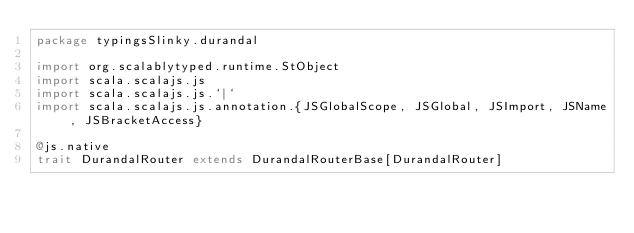<code> <loc_0><loc_0><loc_500><loc_500><_Scala_>package typingsSlinky.durandal

import org.scalablytyped.runtime.StObject
import scala.scalajs.js
import scala.scalajs.js.`|`
import scala.scalajs.js.annotation.{JSGlobalScope, JSGlobal, JSImport, JSName, JSBracketAccess}

@js.native
trait DurandalRouter extends DurandalRouterBase[DurandalRouter]
</code> 